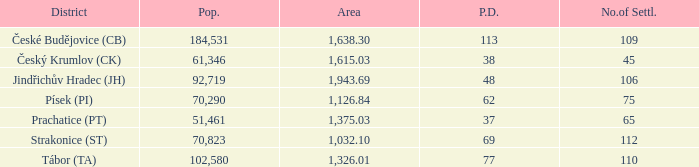What is the lowest population density of Strakonice (st) with more than 112 settlements? None. 